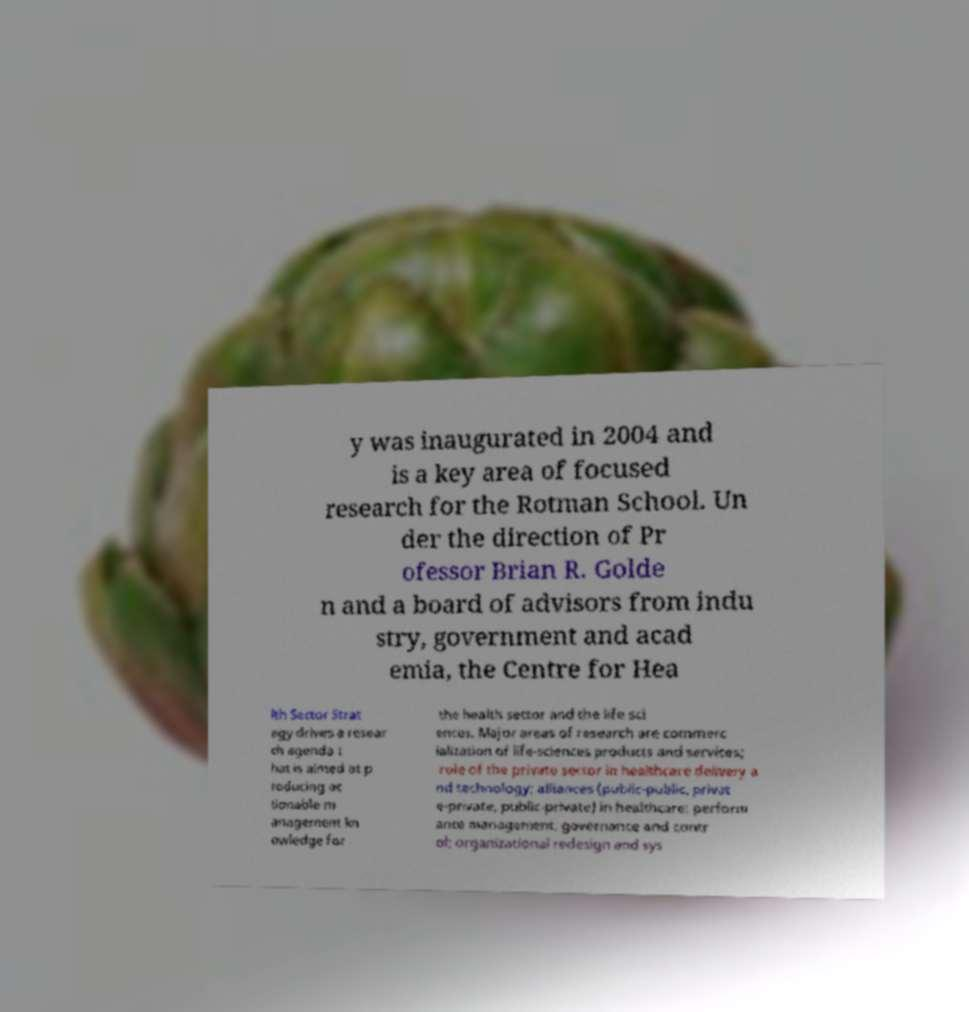Could you assist in decoding the text presented in this image and type it out clearly? y was inaugurated in 2004 and is a key area of focused research for the Rotman School. Un der the direction of Pr ofessor Brian R. Golde n and a board of advisors from indu stry, government and acad emia, the Centre for Hea lth Sector Strat egy drives a resear ch agenda t hat is aimed at p roducing ac tionable m anagement kn owledge for the health sector and the life sci ences. Major areas of research are commerc ialization of life-sciences products and services; role of the private sector in healthcare delivery a nd technology; alliances (public-public, privat e-private, public-private) in healthcare; perform ance management, governance and contr ol; organizational redesign and sys 